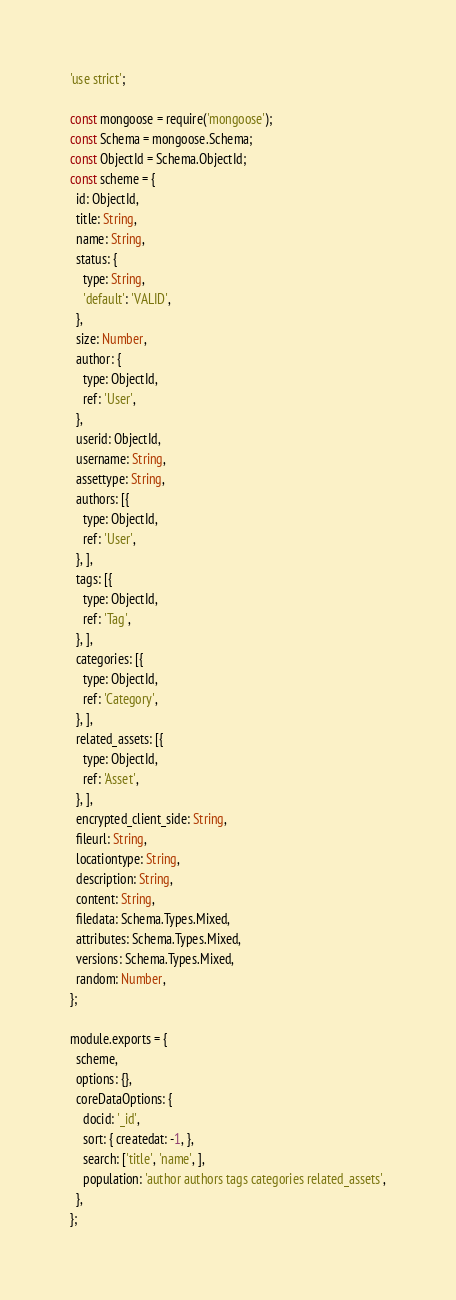Convert code to text. <code><loc_0><loc_0><loc_500><loc_500><_JavaScript_>'use strict';

const mongoose = require('mongoose');
const Schema = mongoose.Schema;
const ObjectId = Schema.ObjectId;
const scheme = {
  id: ObjectId,
  title: String,
  name: String,
  status: {
    type: String,
    'default': 'VALID',
  },
  size: Number,
  author: {
    type: ObjectId,
    ref: 'User',
  },
  userid: ObjectId,
  username: String,
  assettype: String,
  authors: [{
    type: ObjectId,
    ref: 'User',
  }, ],
  tags: [{
    type: ObjectId,
    ref: 'Tag',
  }, ],
  categories: [{
    type: ObjectId,
    ref: 'Category',
  }, ],
  related_assets: [{
    type: ObjectId,
    ref: 'Asset',
  }, ],
  encrypted_client_side: String,
  fileurl: String,
  locationtype: String,
  description: String,
  content: String,
  filedata: Schema.Types.Mixed,
  attributes: Schema.Types.Mixed,
  versions: Schema.Types.Mixed,
  random: Number,
};

module.exports = {
  scheme,
  options: {},
  coreDataOptions: {
    docid: '_id',
    sort: { createdat: -1, },
    search: ['title', 'name', ],
    population: 'author authors tags categories related_assets',
  },
};</code> 